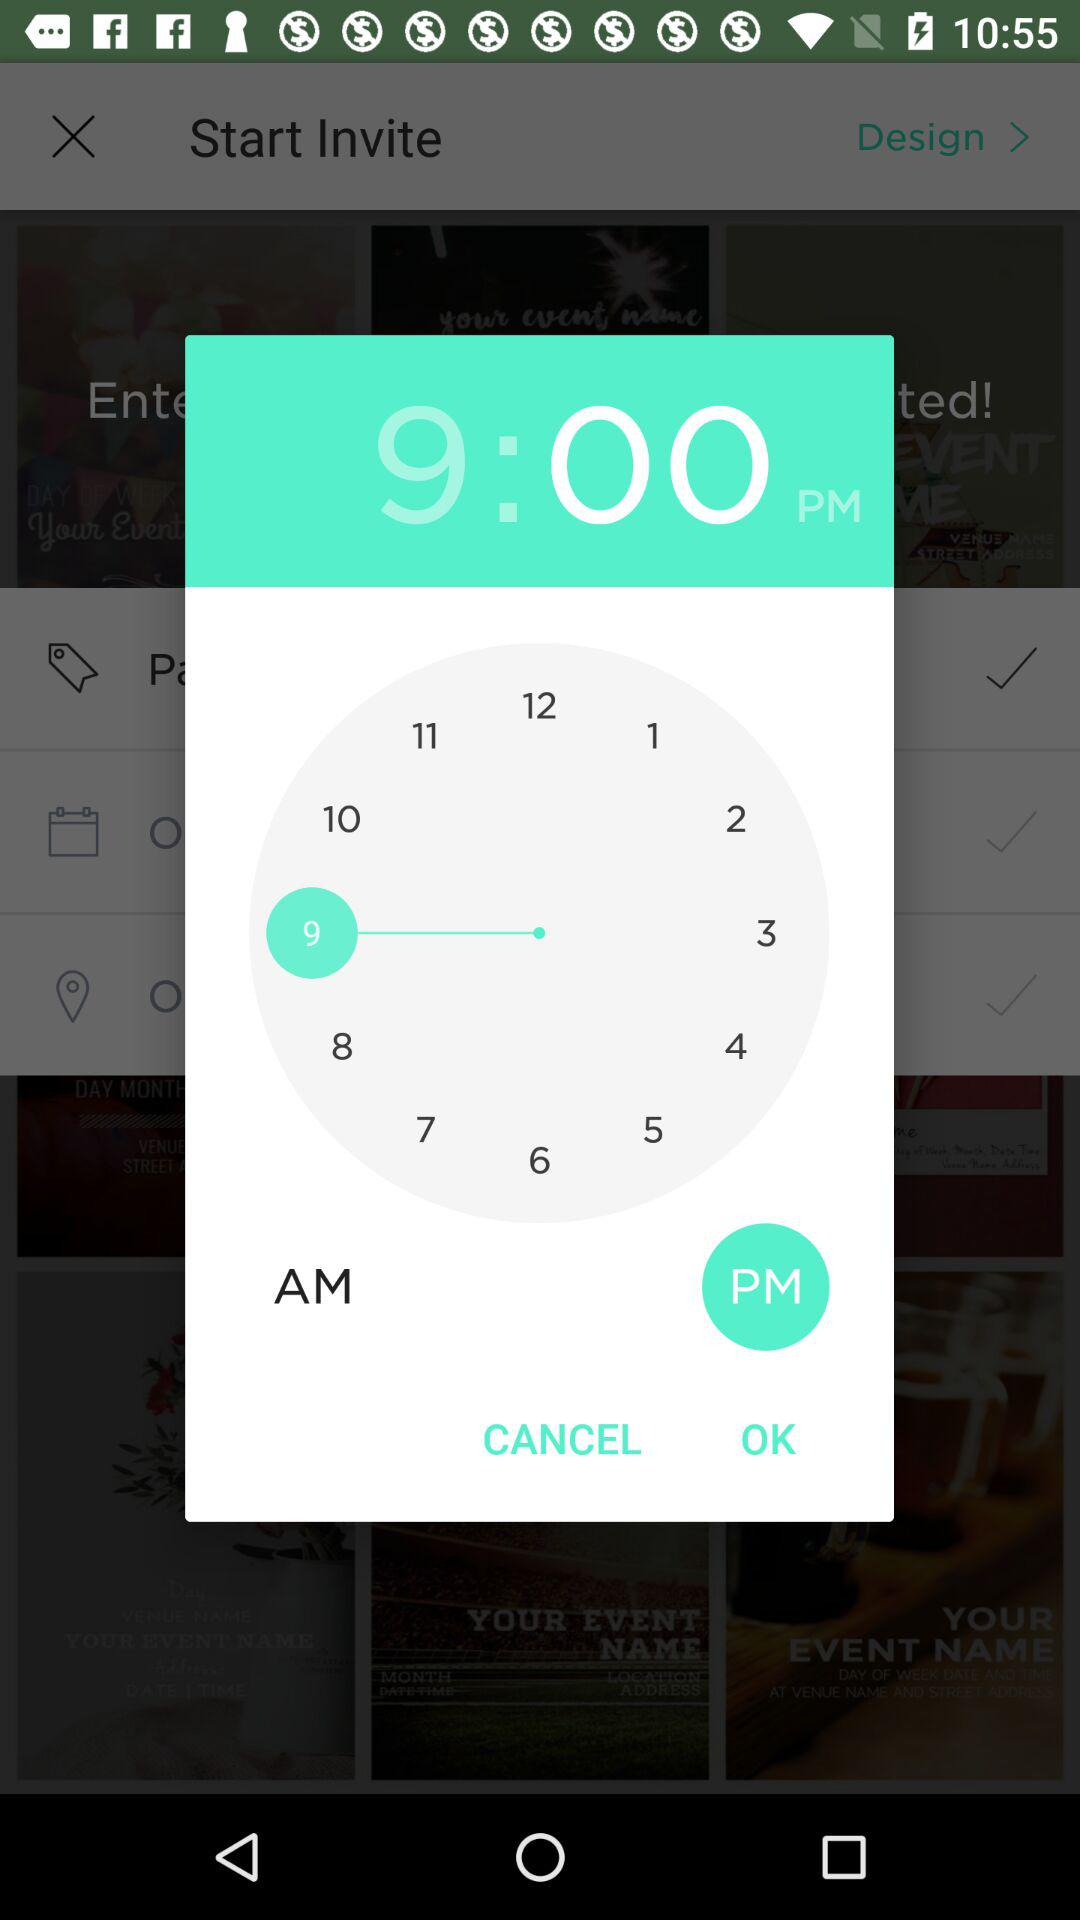What time is set on the clock? The set time is 9 p.m. 